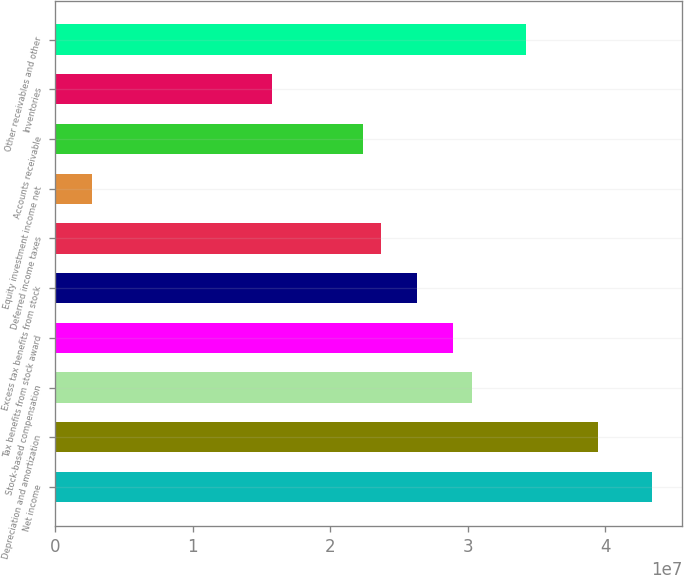Convert chart to OTSL. <chart><loc_0><loc_0><loc_500><loc_500><bar_chart><fcel>Net income<fcel>Depreciation and amortization<fcel>Stock-based compensation<fcel>Tax benefits from stock award<fcel>Excess tax benefits from stock<fcel>Deferred income taxes<fcel>Equity investment income net<fcel>Accounts receivable<fcel>Inventories<fcel>Other receivables and other<nl><fcel>4.34296e+07<fcel>3.94815e+07<fcel>3.02693e+07<fcel>2.89533e+07<fcel>2.63212e+07<fcel>2.36892e+07<fcel>2.63271e+06<fcel>2.23731e+07<fcel>1.5793e+07<fcel>3.42174e+07<nl></chart> 